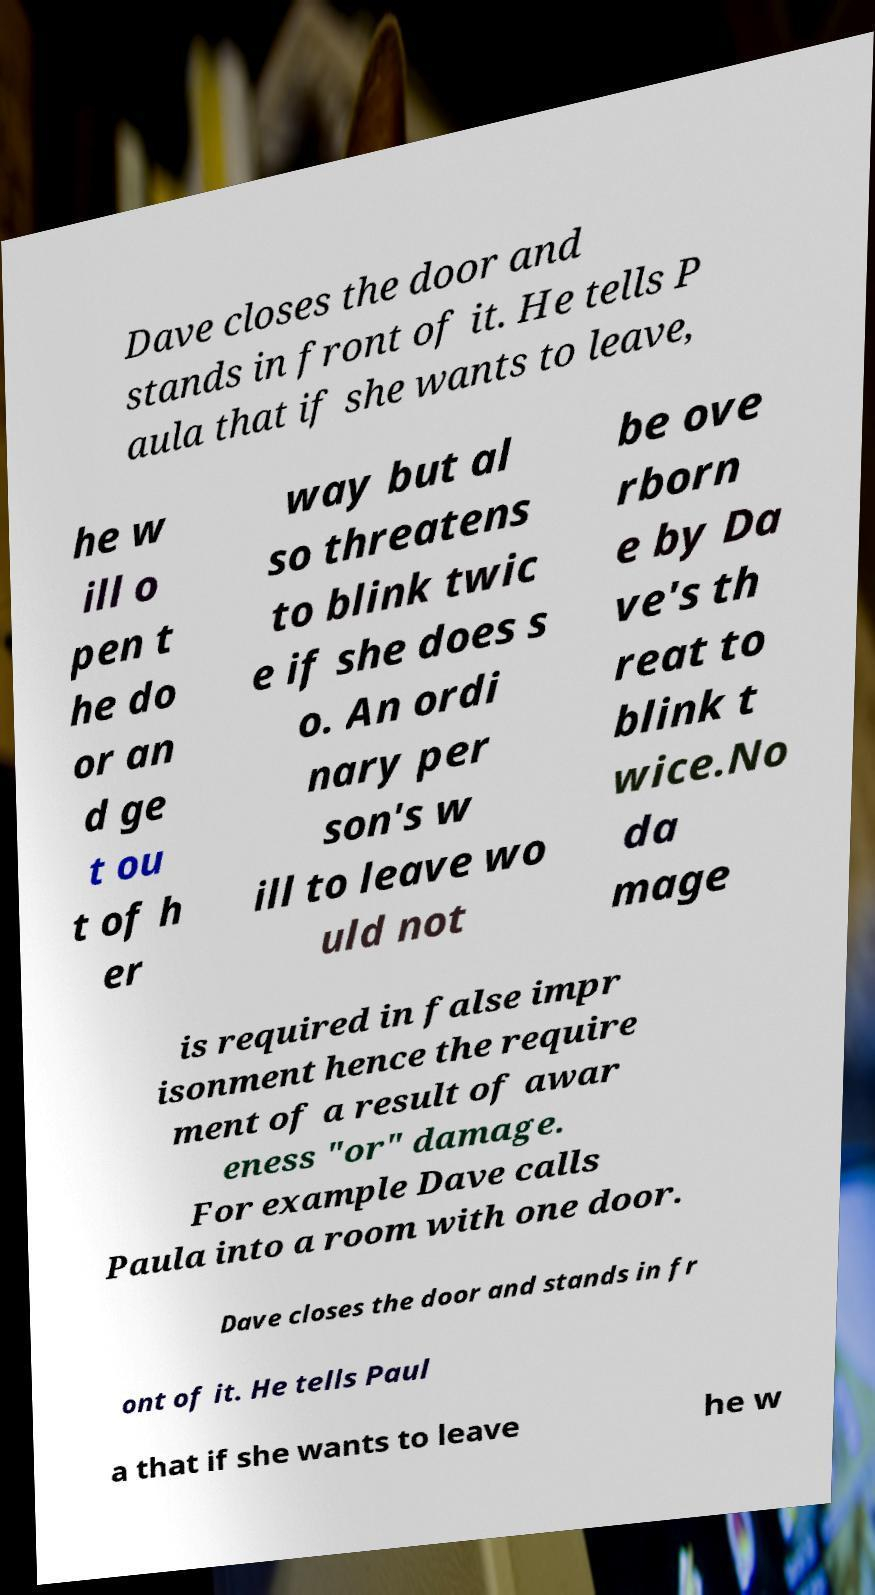Can you read and provide the text displayed in the image?This photo seems to have some interesting text. Can you extract and type it out for me? Dave closes the door and stands in front of it. He tells P aula that if she wants to leave, he w ill o pen t he do or an d ge t ou t of h er way but al so threatens to blink twic e if she does s o. An ordi nary per son's w ill to leave wo uld not be ove rborn e by Da ve's th reat to blink t wice.No da mage is required in false impr isonment hence the require ment of a result of awar eness "or" damage. For example Dave calls Paula into a room with one door. Dave closes the door and stands in fr ont of it. He tells Paul a that if she wants to leave he w 